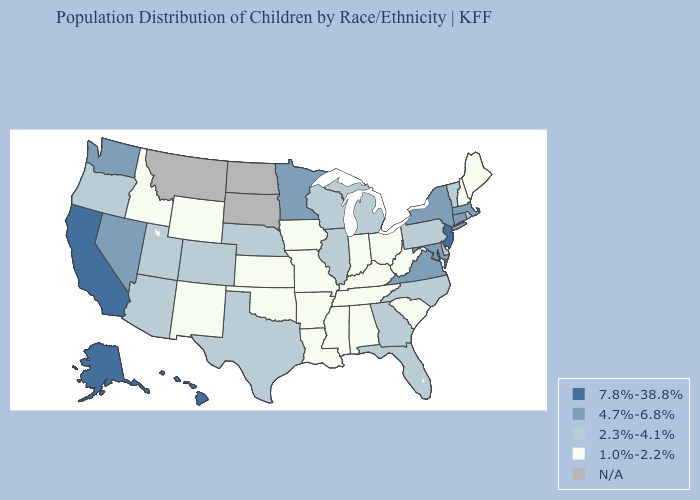Which states have the highest value in the USA?
Keep it brief. Alaska, California, Hawaii, New Jersey. Among the states that border Oklahoma , does New Mexico have the lowest value?
Be succinct. Yes. Which states have the lowest value in the USA?
Give a very brief answer. Alabama, Arkansas, Idaho, Indiana, Iowa, Kansas, Kentucky, Louisiana, Maine, Mississippi, Missouri, New Hampshire, New Mexico, Ohio, Oklahoma, South Carolina, Tennessee, West Virginia, Wyoming. What is the value of New Jersey?
Keep it brief. 7.8%-38.8%. Which states have the highest value in the USA?
Answer briefly. Alaska, California, Hawaii, New Jersey. How many symbols are there in the legend?
Concise answer only. 5. Name the states that have a value in the range 2.3%-4.1%?
Be succinct. Arizona, Colorado, Delaware, Florida, Georgia, Illinois, Michigan, Nebraska, North Carolina, Oregon, Pennsylvania, Rhode Island, Texas, Utah, Vermont, Wisconsin. Name the states that have a value in the range 1.0%-2.2%?
Quick response, please. Alabama, Arkansas, Idaho, Indiana, Iowa, Kansas, Kentucky, Louisiana, Maine, Mississippi, Missouri, New Hampshire, New Mexico, Ohio, Oklahoma, South Carolina, Tennessee, West Virginia, Wyoming. How many symbols are there in the legend?
Keep it brief. 5. What is the value of Montana?
Write a very short answer. N/A. Does Georgia have the lowest value in the South?
Quick response, please. No. Name the states that have a value in the range 2.3%-4.1%?
Keep it brief. Arizona, Colorado, Delaware, Florida, Georgia, Illinois, Michigan, Nebraska, North Carolina, Oregon, Pennsylvania, Rhode Island, Texas, Utah, Vermont, Wisconsin. Name the states that have a value in the range N/A?
Quick response, please. Montana, North Dakota, South Dakota. 